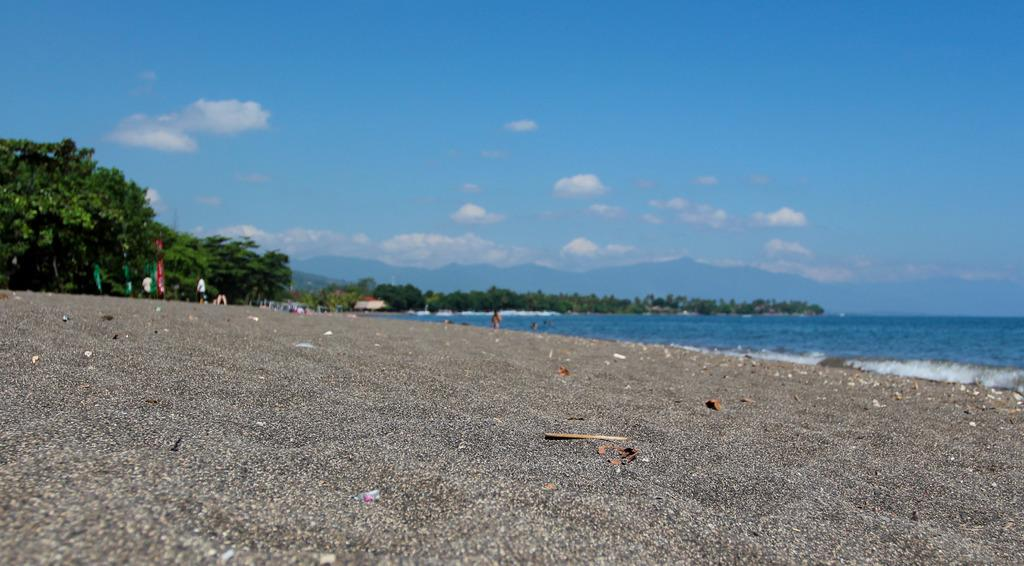What is the main setting of the image? The main setting of the image is a sea. What can be seen in front of the sea? There are persons in front of the sea. What is visible at the top of the image? The sky is visible at the top of the image. What type of creature is responsible for the condition of the sea in the image? There is no creature present in the image, and the condition of the sea is not mentioned in the provided facts. 